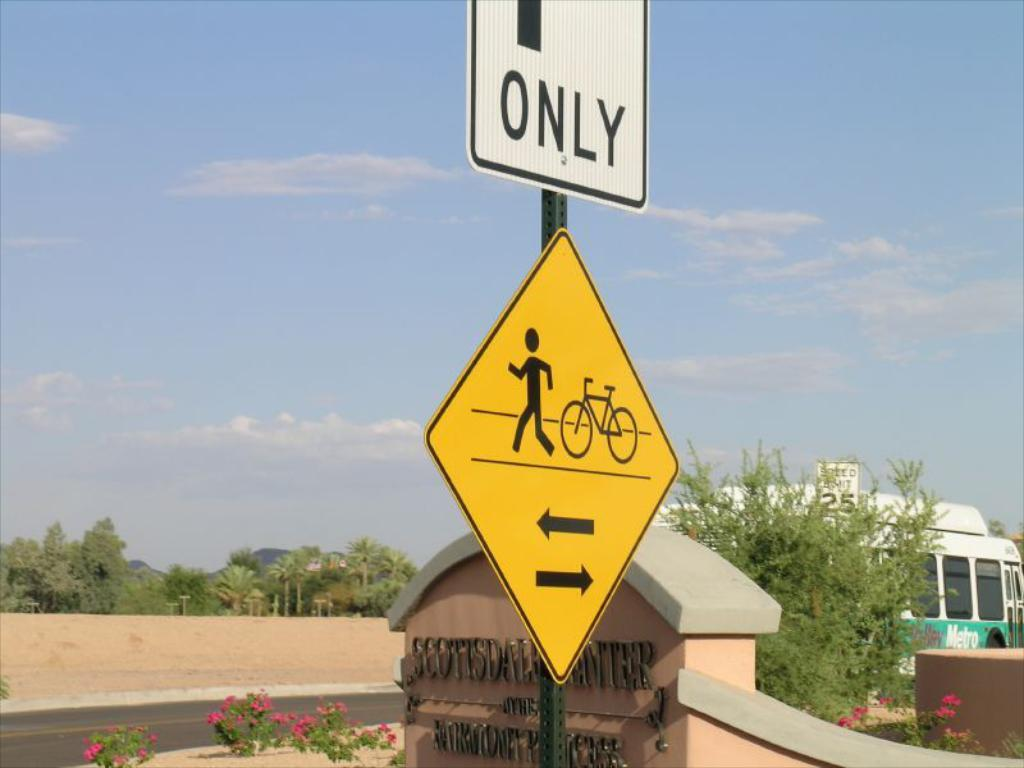<image>
Summarize the visual content of the image. A couple street sings in front of a sign for the Scottsdale Center. 